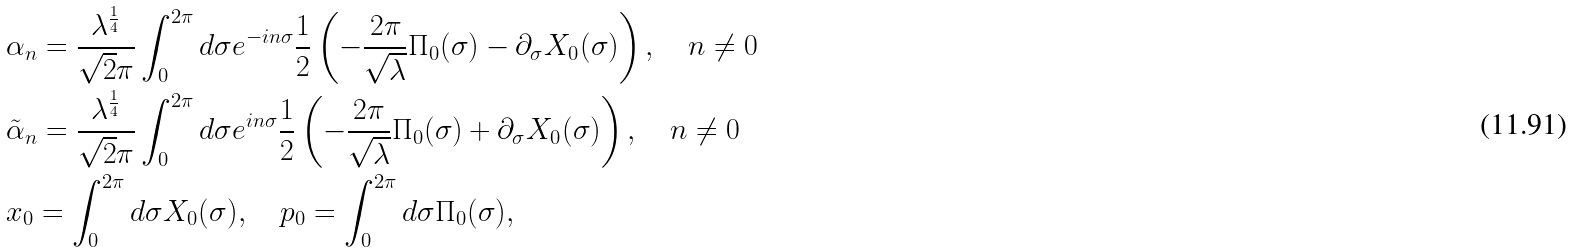<formula> <loc_0><loc_0><loc_500><loc_500>& \alpha _ { n } = \frac { \lambda ^ { \frac { 1 } { 4 } } } { \sqrt { 2 } \pi } \int _ { 0 } ^ { 2 \pi } d \sigma e ^ { - i n \sigma } \frac { 1 } { 2 } \left ( - \frac { 2 \pi } { \sqrt { \lambda } } \Pi _ { 0 } ( \sigma ) - \partial _ { \sigma } X _ { 0 } ( \sigma ) \right ) , \quad n \neq 0 \\ & \tilde { \alpha } _ { n } = \frac { \lambda ^ { \frac { 1 } { 4 } } } { \sqrt { 2 } \pi } \int _ { 0 } ^ { 2 \pi } d \sigma e ^ { i n \sigma } \frac { 1 } { 2 } \left ( - \frac { 2 \pi } { \sqrt { \lambda } } \Pi _ { 0 } ( \sigma ) + \partial _ { \sigma } X _ { 0 } ( \sigma ) \right ) , \quad n \neq 0 \\ & x _ { 0 } = \int _ { 0 } ^ { 2 \pi } d \sigma X _ { 0 } ( \sigma ) , \quad p _ { 0 } = \int _ { 0 } ^ { 2 \pi } d \sigma \Pi _ { 0 } ( \sigma ) ,</formula> 